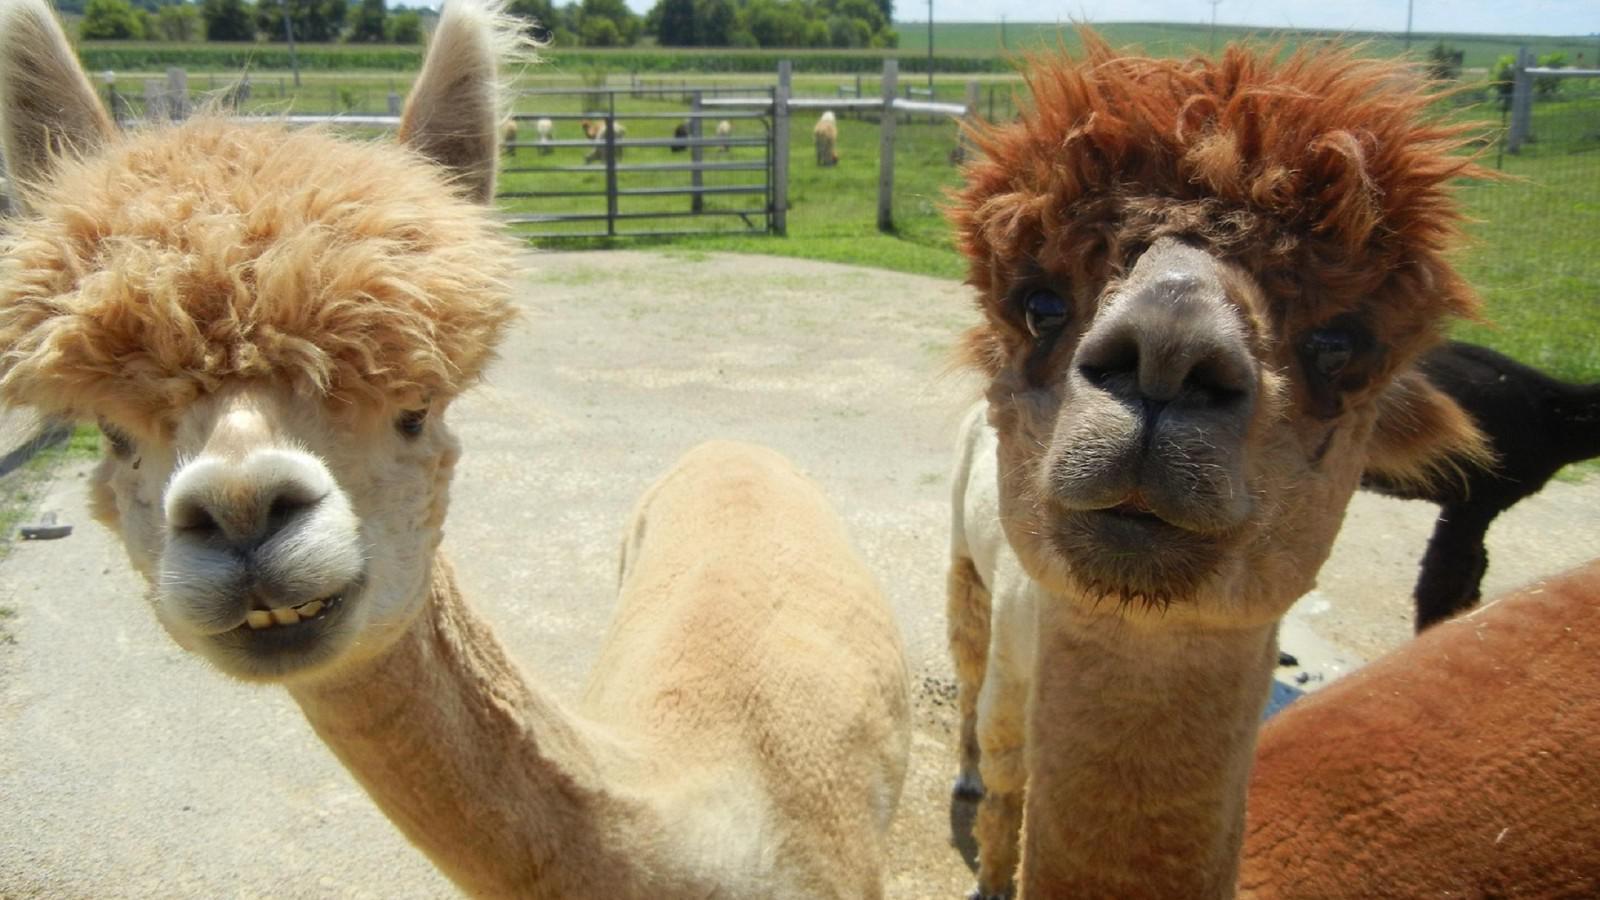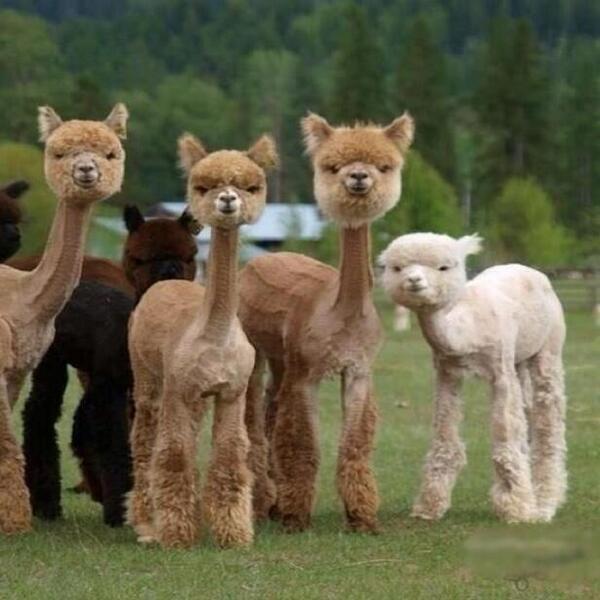The first image is the image on the left, the second image is the image on the right. Evaluate the accuracy of this statement regarding the images: "Two llamas are wearing bow ties and little hats.". Is it true? Answer yes or no. No. 